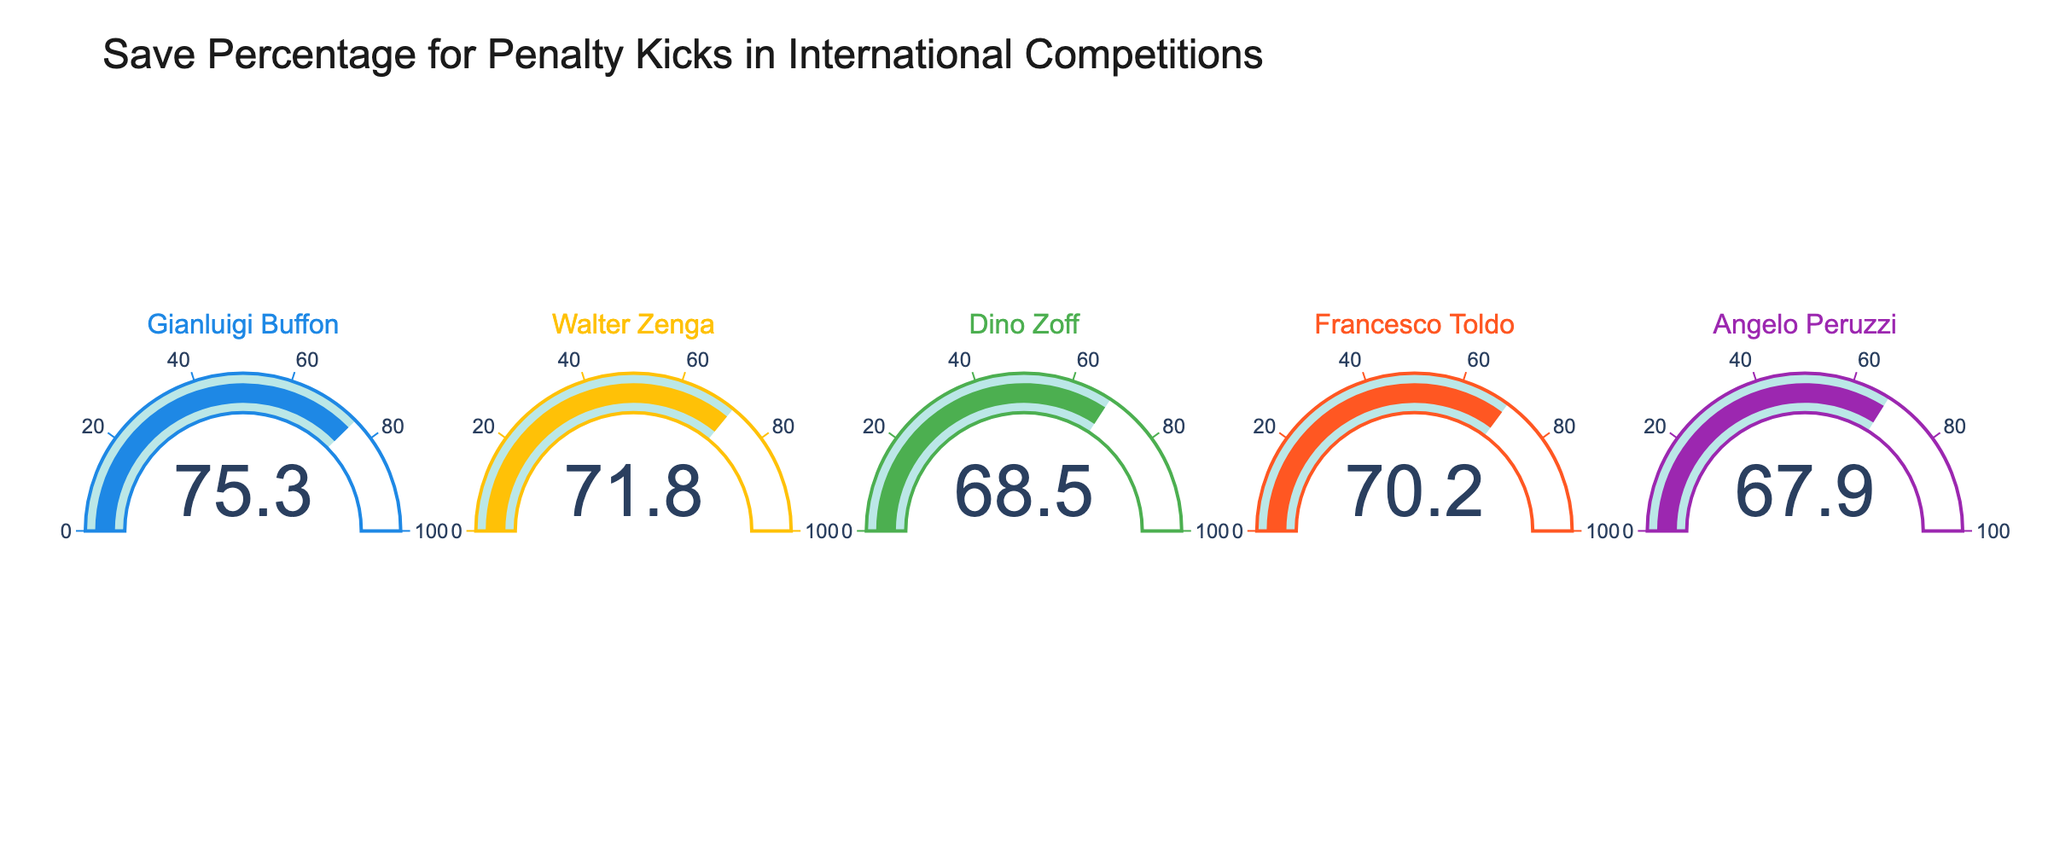What's the title of the figure? The title is usually found at the top of the chart and provides the context for what the figure represents. In this case, it should describe the main theme of the gauges.
Answer: Save Percentage for Penalty Kicks in International Competitions How many goalkeepers' save percentages are displayed in the figure? Count the number of gauges displayed, as each gauge represents a different goalkeeper's save percentage. There are 5 goalkeepers listed in the data.
Answer: 5 Which goalkeeper has the highest save percentage shown in the figure? Compare the values on each gauge to determine which is the highest. Buffon has the highest save percentage at 75.3%.
Answer: Gianluigi Buffon What is the average save percentage of the goalkeepers? To find the average, sum all the save percentages and divide by the number of goalkeepers. (75.3 + 71.8 + 68.5 + 70.2 + 67.9) / 5 = 70.74
Answer: 70.74 Which two goalkeepers have the smallest difference in save percentages? Calculate the difference between each pair of goalkeepers. The smallest difference is between Zenga (71.8) and Toldo (70.2), which is 1.6.
Answer: Walter Zenga and Francesco Toldo Who has a better save percentage, Buffon or Zoff? Directly compare the save percentages of Buffon (75.3) and Zoff (68.5). Buffon has a better save percentage.
Answer: Gianluigi Buffon What is the range of the save percentages displayed in the figure? Calculate the difference between the highest and lowest save percentages. Highest is Buffon with 75.3 and lowest is Peruzzi with 67.9. The range is 75.3 - 67.9 = 7.4.
Answer: 7.4 How does Toldo's save percentage compare to the average save percentage of all goalkeepers? Calculate the average save percentage as previously done (70.74). Toldo's save percentage is 70.2, which is slightly below the average.
Answer: Below Which color is used for Buffon's gauge? Identify the color of the bar in Buffon's gauge. It is usually blue.
Answer: Blue 